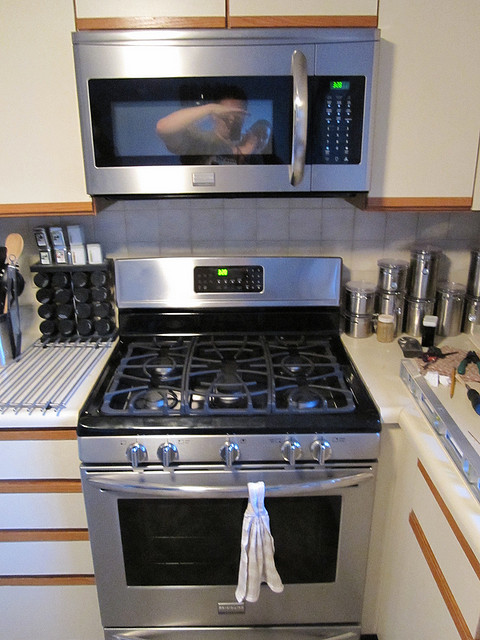What type of stove is in the picture? The stove in the picture is a gas range with a stainless steel finish. Can you tell how many burners it has? Sure, the stove has six burners of varying sizes, allowing for versatile cooking options. 